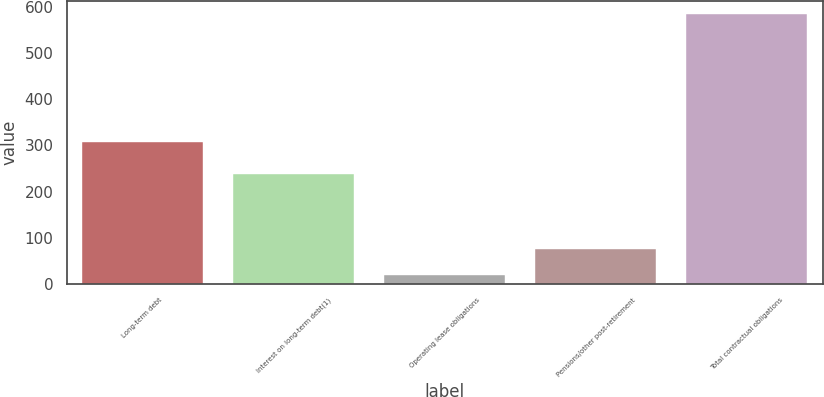Convert chart to OTSL. <chart><loc_0><loc_0><loc_500><loc_500><bar_chart><fcel>Long-term debt<fcel>Interest on long-term debt(1)<fcel>Operating lease obligations<fcel>Pensions/other post-retirement<fcel>Total contractual obligations<nl><fcel>306.5<fcel>237.2<fcel>18.2<fcel>74.82<fcel>584.4<nl></chart> 